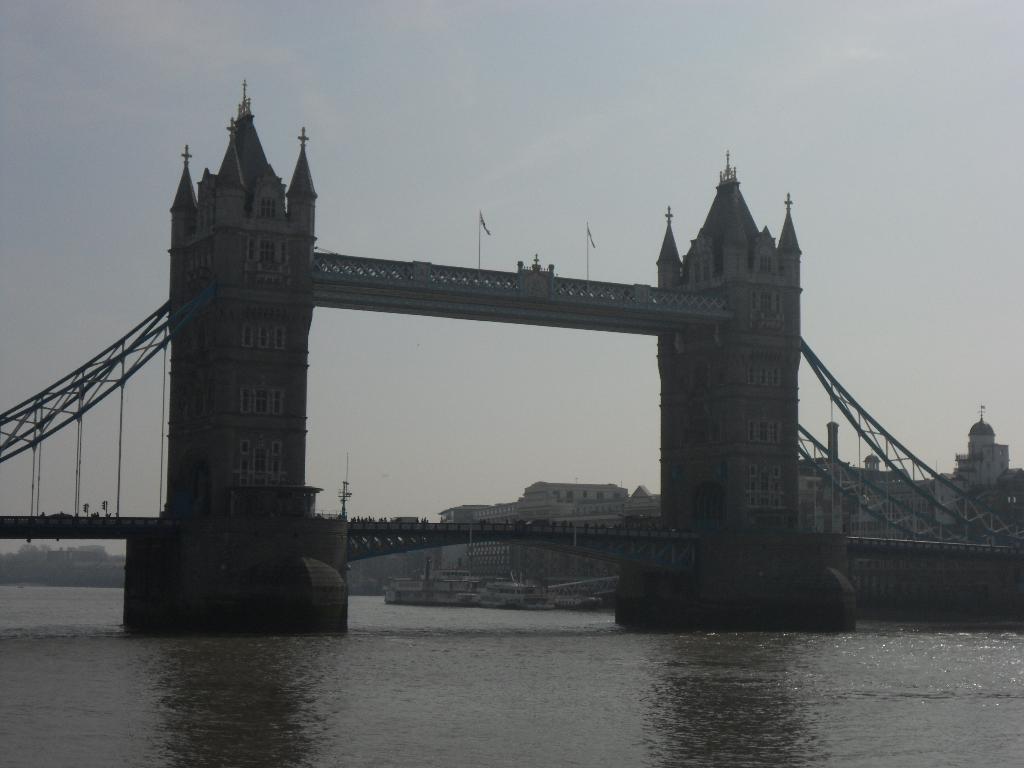How would you summarize this image in a sentence or two? In this picture there is tower bridge in the center of the image and there is water at the bottom side of the image, there are buildings in the background area of the image. 